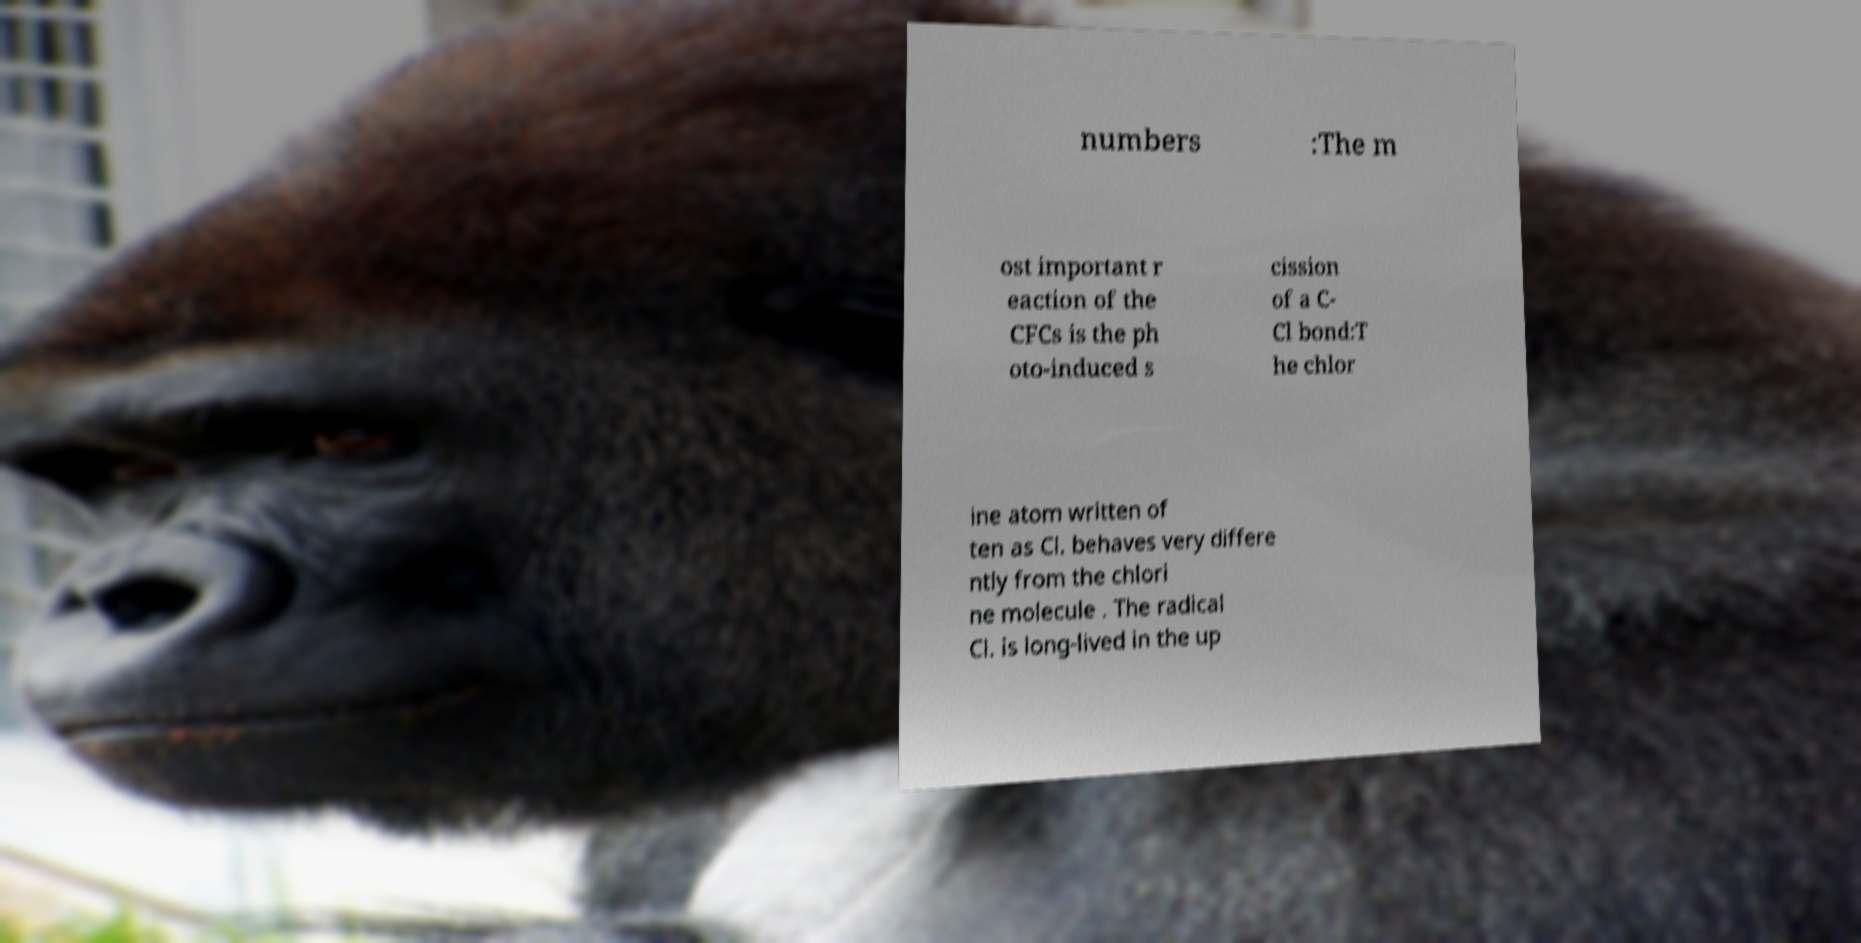For documentation purposes, I need the text within this image transcribed. Could you provide that? numbers :The m ost important r eaction of the CFCs is the ph oto-induced s cission of a C- Cl bond:T he chlor ine atom written of ten as Cl. behaves very differe ntly from the chlori ne molecule . The radical Cl. is long-lived in the up 